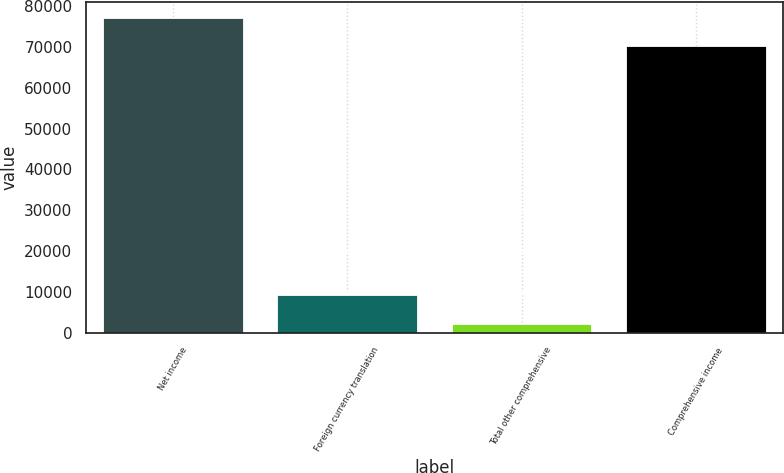Convert chart to OTSL. <chart><loc_0><loc_0><loc_500><loc_500><bar_chart><fcel>Net income<fcel>Foreign currency translation<fcel>Total other comprehensive<fcel>Comprehensive income<nl><fcel>77138.6<fcel>9115.6<fcel>2103<fcel>70126<nl></chart> 